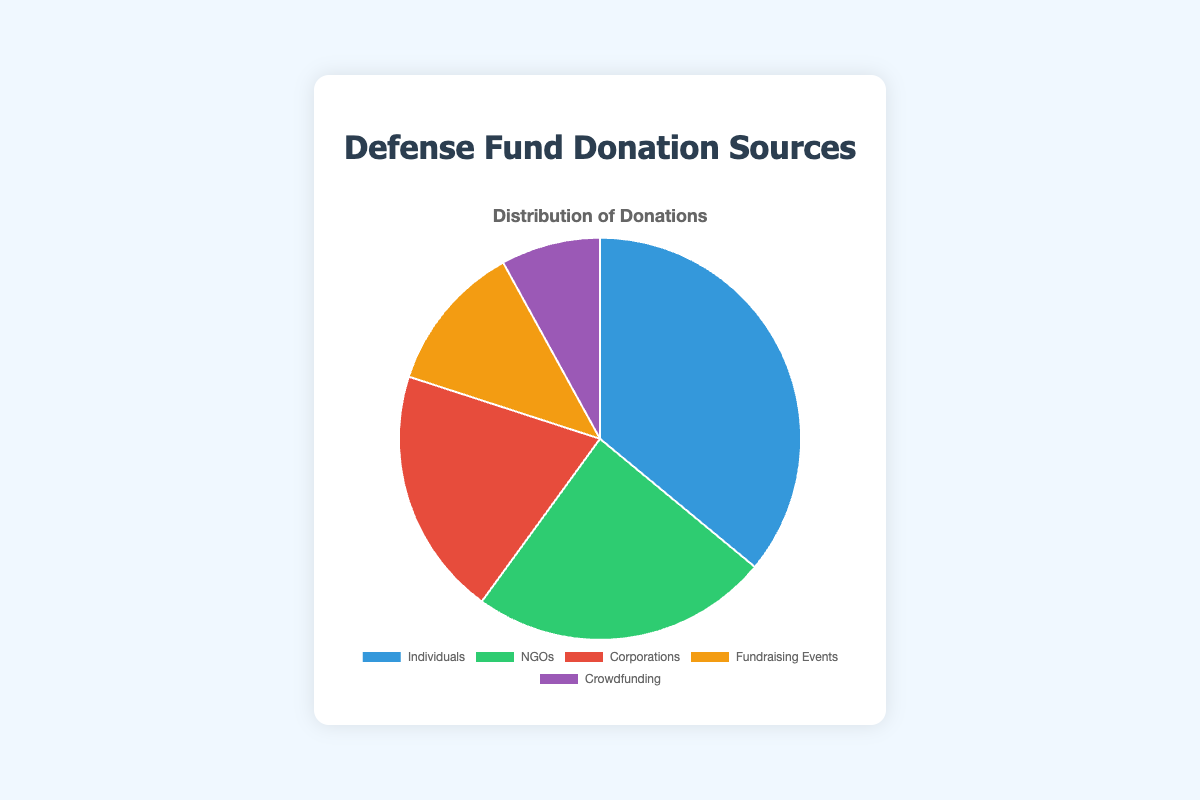What's the largest source of donations? By looking at the values in the pie chart, we can identify the largest segment is for "Individuals" with $45,000.
Answer: Individuals Which source contributed the least to the fund? By comparing all segments, "Crowdfunding" has the smallest slice of the pie, contributing $10,000.
Answer: Crowdfunding How much more did NGOs contribute compared to crowdfunding? NGOs contributed $30,000 and crowdfunding contributed $10,000. The difference is calculated as $30,000 - $10,000.
Answer: $20,000 What’s the combined total of donations from Corporations and Fundraising Events? Corporations contributed $25,000 and Fundraising Events contributed $15,000. Adding these together gives $25,000 + $15,000.
Answer: $40,000 If the total fund is $125,000, what percentage of donations came from Individuals? The amount from Individuals is $45,000. The percentage is calculated by ($45,000 / $125,000) * 100.
Answer: 36% Identify two sources whose combined contribution is the same as the contribution from Individuals. Corporations ($25,000) and Fundraising Events ($15,000) contribute $40,000 together, which is close but less than Individuals. NGOs ($30,000) and Crowdfunding ($10,000) together add up to $40,000.
Answer: NGOs and Crowdfunding What's the average amount donated by the notable donors from Individuals? Sum the notable donations from Individuals ($10,000 + $8,000 + $5,000 + $7,000 + $12,000 = $42,000) and divide by the number of donations (5).
Answer: $8,400 Which source has the highest number of notable donations/events/campaigns listed? By counting, Individuals have 5 notable donations, NGOs have 3, Corporations have 3, Fundraising Events have 3 notable events, and Crowdfunding has 3 notable campaigns.
Answer: Individuals Which color represents the Corporations' donations in the pie chart? The Corporations' segment in the pie chart is red.
Answer: Red 